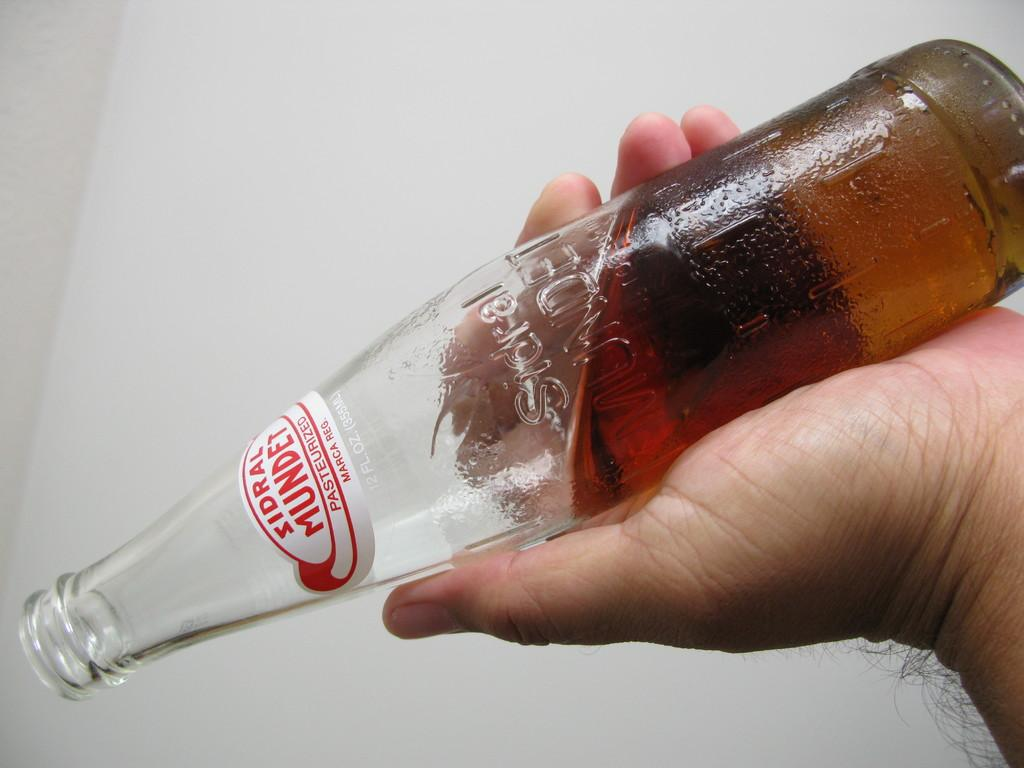<image>
Offer a succinct explanation of the picture presented. a person holds a bottle of Sidral Mundet 